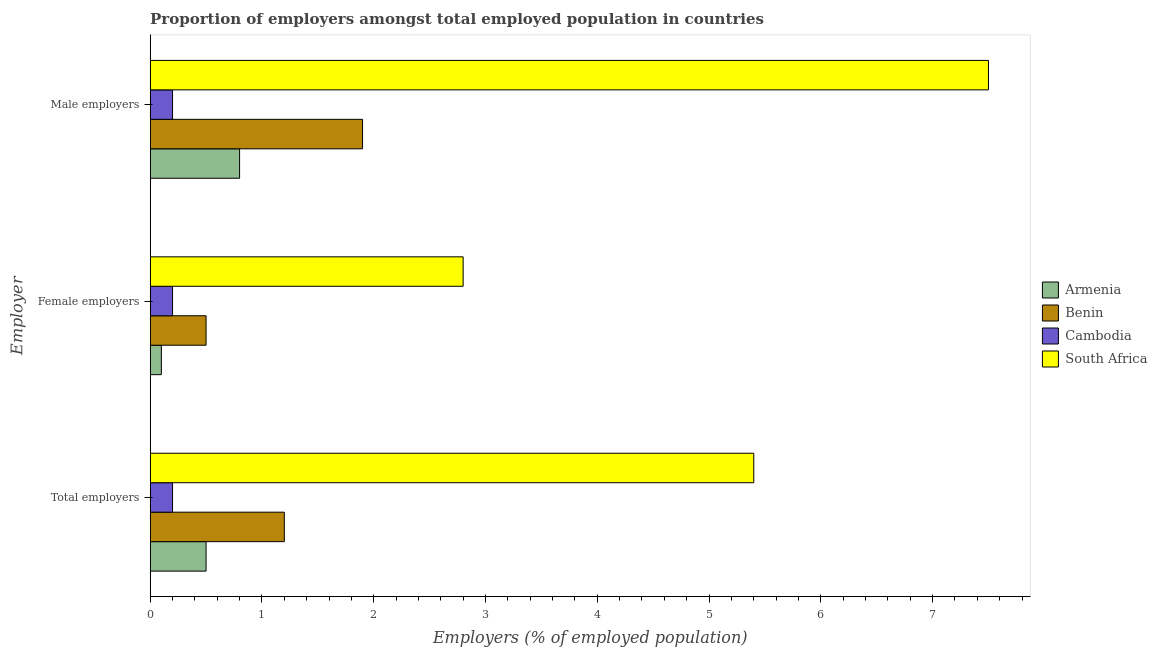How many different coloured bars are there?
Your answer should be compact. 4. How many bars are there on the 1st tick from the bottom?
Your response must be concise. 4. What is the label of the 1st group of bars from the top?
Provide a short and direct response. Male employers. What is the percentage of total employers in Benin?
Provide a succinct answer. 1.2. Across all countries, what is the maximum percentage of total employers?
Offer a terse response. 5.4. Across all countries, what is the minimum percentage of total employers?
Your response must be concise. 0.2. In which country was the percentage of female employers maximum?
Make the answer very short. South Africa. In which country was the percentage of female employers minimum?
Give a very brief answer. Armenia. What is the total percentage of total employers in the graph?
Give a very brief answer. 7.3. What is the difference between the percentage of total employers in Benin and that in Cambodia?
Your answer should be compact. 1. What is the difference between the percentage of female employers in Benin and the percentage of male employers in Cambodia?
Ensure brevity in your answer.  0.3. What is the average percentage of total employers per country?
Your answer should be compact. 1.83. What is the difference between the percentage of female employers and percentage of male employers in Cambodia?
Offer a very short reply. 0. What is the ratio of the percentage of male employers in Cambodia to that in Benin?
Give a very brief answer. 0.11. Is the difference between the percentage of female employers in Armenia and Cambodia greater than the difference between the percentage of male employers in Armenia and Cambodia?
Make the answer very short. No. What is the difference between the highest and the second highest percentage of male employers?
Offer a terse response. 5.6. What is the difference between the highest and the lowest percentage of male employers?
Offer a terse response. 7.3. In how many countries, is the percentage of male employers greater than the average percentage of male employers taken over all countries?
Ensure brevity in your answer.  1. Is the sum of the percentage of total employers in Benin and South Africa greater than the maximum percentage of female employers across all countries?
Make the answer very short. Yes. What does the 3rd bar from the top in Female employers represents?
Provide a succinct answer. Benin. What does the 2nd bar from the bottom in Female employers represents?
Give a very brief answer. Benin. Is it the case that in every country, the sum of the percentage of total employers and percentage of female employers is greater than the percentage of male employers?
Offer a terse response. No. How many countries are there in the graph?
Your response must be concise. 4. What is the difference between two consecutive major ticks on the X-axis?
Your answer should be very brief. 1. Does the graph contain grids?
Your answer should be very brief. No. Where does the legend appear in the graph?
Your answer should be compact. Center right. How are the legend labels stacked?
Your answer should be very brief. Vertical. What is the title of the graph?
Make the answer very short. Proportion of employers amongst total employed population in countries. Does "Netherlands" appear as one of the legend labels in the graph?
Your answer should be compact. No. What is the label or title of the X-axis?
Your answer should be very brief. Employers (% of employed population). What is the label or title of the Y-axis?
Your answer should be very brief. Employer. What is the Employers (% of employed population) in Armenia in Total employers?
Your answer should be very brief. 0.5. What is the Employers (% of employed population) in Benin in Total employers?
Your answer should be compact. 1.2. What is the Employers (% of employed population) in Cambodia in Total employers?
Ensure brevity in your answer.  0.2. What is the Employers (% of employed population) of South Africa in Total employers?
Your answer should be very brief. 5.4. What is the Employers (% of employed population) in Armenia in Female employers?
Provide a short and direct response. 0.1. What is the Employers (% of employed population) in Cambodia in Female employers?
Provide a succinct answer. 0.2. What is the Employers (% of employed population) in South Africa in Female employers?
Give a very brief answer. 2.8. What is the Employers (% of employed population) of Armenia in Male employers?
Give a very brief answer. 0.8. What is the Employers (% of employed population) in Benin in Male employers?
Provide a succinct answer. 1.9. What is the Employers (% of employed population) of Cambodia in Male employers?
Make the answer very short. 0.2. Across all Employer, what is the maximum Employers (% of employed population) of Armenia?
Provide a short and direct response. 0.8. Across all Employer, what is the maximum Employers (% of employed population) in Benin?
Make the answer very short. 1.9. Across all Employer, what is the maximum Employers (% of employed population) in Cambodia?
Your answer should be very brief. 0.2. Across all Employer, what is the minimum Employers (% of employed population) of Armenia?
Provide a short and direct response. 0.1. Across all Employer, what is the minimum Employers (% of employed population) in Benin?
Give a very brief answer. 0.5. Across all Employer, what is the minimum Employers (% of employed population) of Cambodia?
Your answer should be very brief. 0.2. Across all Employer, what is the minimum Employers (% of employed population) of South Africa?
Offer a terse response. 2.8. What is the total Employers (% of employed population) in Armenia in the graph?
Provide a short and direct response. 1.4. What is the total Employers (% of employed population) of Benin in the graph?
Keep it short and to the point. 3.6. What is the difference between the Employers (% of employed population) in Armenia in Total employers and that in Female employers?
Provide a short and direct response. 0.4. What is the difference between the Employers (% of employed population) in Benin in Total employers and that in Female employers?
Offer a very short reply. 0.7. What is the difference between the Employers (% of employed population) of Cambodia in Total employers and that in Female employers?
Offer a terse response. 0. What is the difference between the Employers (% of employed population) of South Africa in Total employers and that in Female employers?
Offer a very short reply. 2.6. What is the difference between the Employers (% of employed population) in Cambodia in Total employers and that in Male employers?
Offer a very short reply. 0. What is the difference between the Employers (% of employed population) of Benin in Female employers and that in Male employers?
Provide a succinct answer. -1.4. What is the difference between the Employers (% of employed population) of South Africa in Female employers and that in Male employers?
Give a very brief answer. -4.7. What is the difference between the Employers (% of employed population) in Armenia in Total employers and the Employers (% of employed population) in Cambodia in Female employers?
Keep it short and to the point. 0.3. What is the difference between the Employers (% of employed population) of Benin in Total employers and the Employers (% of employed population) of Cambodia in Female employers?
Your response must be concise. 1. What is the difference between the Employers (% of employed population) in Armenia in Total employers and the Employers (% of employed population) in Benin in Male employers?
Offer a very short reply. -1.4. What is the difference between the Employers (% of employed population) of Armenia in Total employers and the Employers (% of employed population) of South Africa in Male employers?
Ensure brevity in your answer.  -7. What is the difference between the Employers (% of employed population) of Cambodia in Total employers and the Employers (% of employed population) of South Africa in Male employers?
Your response must be concise. -7.3. What is the difference between the Employers (% of employed population) in Armenia in Female employers and the Employers (% of employed population) in Cambodia in Male employers?
Offer a very short reply. -0.1. What is the difference between the Employers (% of employed population) in Cambodia in Female employers and the Employers (% of employed population) in South Africa in Male employers?
Your response must be concise. -7.3. What is the average Employers (% of employed population) in Armenia per Employer?
Your response must be concise. 0.47. What is the average Employers (% of employed population) of Cambodia per Employer?
Provide a succinct answer. 0.2. What is the average Employers (% of employed population) in South Africa per Employer?
Offer a very short reply. 5.23. What is the difference between the Employers (% of employed population) of Armenia and Employers (% of employed population) of Benin in Total employers?
Provide a succinct answer. -0.7. What is the difference between the Employers (% of employed population) in Armenia and Employers (% of employed population) in South Africa in Total employers?
Offer a very short reply. -4.9. What is the difference between the Employers (% of employed population) in Benin and Employers (% of employed population) in South Africa in Total employers?
Keep it short and to the point. -4.2. What is the difference between the Employers (% of employed population) of Cambodia and Employers (% of employed population) of South Africa in Total employers?
Make the answer very short. -5.2. What is the difference between the Employers (% of employed population) in Benin and Employers (% of employed population) in Cambodia in Female employers?
Ensure brevity in your answer.  0.3. What is the difference between the Employers (% of employed population) in Benin and Employers (% of employed population) in South Africa in Female employers?
Provide a short and direct response. -2.3. What is the difference between the Employers (% of employed population) of Cambodia and Employers (% of employed population) of South Africa in Female employers?
Provide a succinct answer. -2.6. What is the difference between the Employers (% of employed population) in Armenia and Employers (% of employed population) in Benin in Male employers?
Your response must be concise. -1.1. What is the difference between the Employers (% of employed population) of Benin and Employers (% of employed population) of South Africa in Male employers?
Offer a terse response. -5.6. What is the difference between the Employers (% of employed population) of Cambodia and Employers (% of employed population) of South Africa in Male employers?
Your response must be concise. -7.3. What is the ratio of the Employers (% of employed population) in South Africa in Total employers to that in Female employers?
Give a very brief answer. 1.93. What is the ratio of the Employers (% of employed population) in Armenia in Total employers to that in Male employers?
Your answer should be very brief. 0.62. What is the ratio of the Employers (% of employed population) in Benin in Total employers to that in Male employers?
Provide a succinct answer. 0.63. What is the ratio of the Employers (% of employed population) of Cambodia in Total employers to that in Male employers?
Your answer should be very brief. 1. What is the ratio of the Employers (% of employed population) of South Africa in Total employers to that in Male employers?
Your answer should be compact. 0.72. What is the ratio of the Employers (% of employed population) of Benin in Female employers to that in Male employers?
Ensure brevity in your answer.  0.26. What is the ratio of the Employers (% of employed population) in Cambodia in Female employers to that in Male employers?
Provide a short and direct response. 1. What is the ratio of the Employers (% of employed population) in South Africa in Female employers to that in Male employers?
Your answer should be very brief. 0.37. What is the difference between the highest and the second highest Employers (% of employed population) of Armenia?
Offer a terse response. 0.3. What is the difference between the highest and the second highest Employers (% of employed population) in Benin?
Give a very brief answer. 0.7. What is the difference between the highest and the second highest Employers (% of employed population) in Cambodia?
Ensure brevity in your answer.  0. What is the difference between the highest and the lowest Employers (% of employed population) in Benin?
Your answer should be compact. 1.4. 